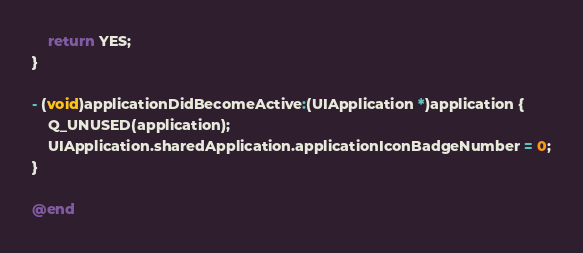Convert code to text. <code><loc_0><loc_0><loc_500><loc_500><_ObjectiveC_>    return YES;
}

- (void)applicationDidBecomeActive:(UIApplication *)application {
    Q_UNUSED(application);
    UIApplication.sharedApplication.applicationIconBadgeNumber = 0;
}

@end
</code> 